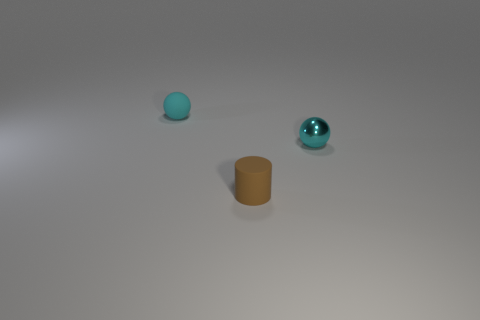There is a small cyan matte ball; are there any spheres in front of it?
Provide a short and direct response. Yes. How many metallic objects are there?
Your response must be concise. 1. What number of rubber things are in front of the tiny brown rubber thing in front of the cyan metallic ball?
Offer a very short reply. 0. Do the rubber sphere and the rubber thing that is in front of the cyan metal thing have the same color?
Provide a succinct answer. No. How many other rubber objects are the same shape as the small brown object?
Offer a terse response. 0. There is a tiny cyan object that is left of the small cyan metal sphere; what is it made of?
Give a very brief answer. Rubber. There is a tiny matte object that is to the right of the matte ball; does it have the same shape as the small cyan shiny object?
Keep it short and to the point. No. Are there any brown matte objects of the same size as the cyan matte object?
Offer a very short reply. Yes. There is a tiny cyan metal object; is its shape the same as the tiny cyan object that is behind the tiny cyan metallic sphere?
Your answer should be compact. Yes. There is a thing that is the same color as the tiny metallic ball; what shape is it?
Provide a succinct answer. Sphere. 